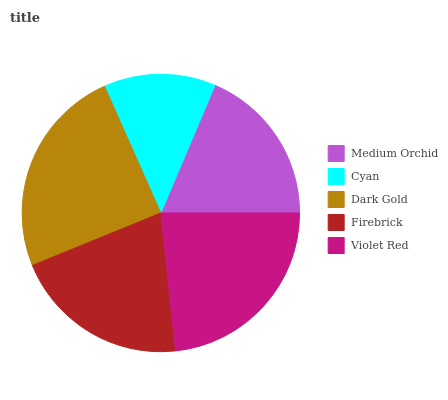Is Cyan the minimum?
Answer yes or no. Yes. Is Dark Gold the maximum?
Answer yes or no. Yes. Is Dark Gold the minimum?
Answer yes or no. No. Is Cyan the maximum?
Answer yes or no. No. Is Dark Gold greater than Cyan?
Answer yes or no. Yes. Is Cyan less than Dark Gold?
Answer yes or no. Yes. Is Cyan greater than Dark Gold?
Answer yes or no. No. Is Dark Gold less than Cyan?
Answer yes or no. No. Is Firebrick the high median?
Answer yes or no. Yes. Is Firebrick the low median?
Answer yes or no. Yes. Is Dark Gold the high median?
Answer yes or no. No. Is Medium Orchid the low median?
Answer yes or no. No. 